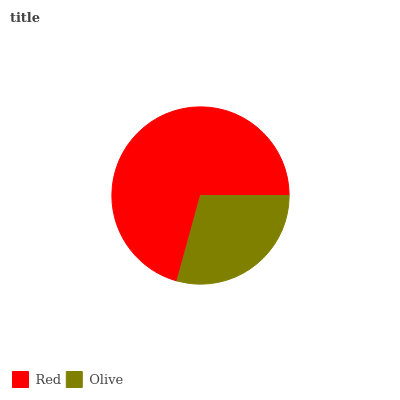Is Olive the minimum?
Answer yes or no. Yes. Is Red the maximum?
Answer yes or no. Yes. Is Olive the maximum?
Answer yes or no. No. Is Red greater than Olive?
Answer yes or no. Yes. Is Olive less than Red?
Answer yes or no. Yes. Is Olive greater than Red?
Answer yes or no. No. Is Red less than Olive?
Answer yes or no. No. Is Red the high median?
Answer yes or no. Yes. Is Olive the low median?
Answer yes or no. Yes. Is Olive the high median?
Answer yes or no. No. Is Red the low median?
Answer yes or no. No. 